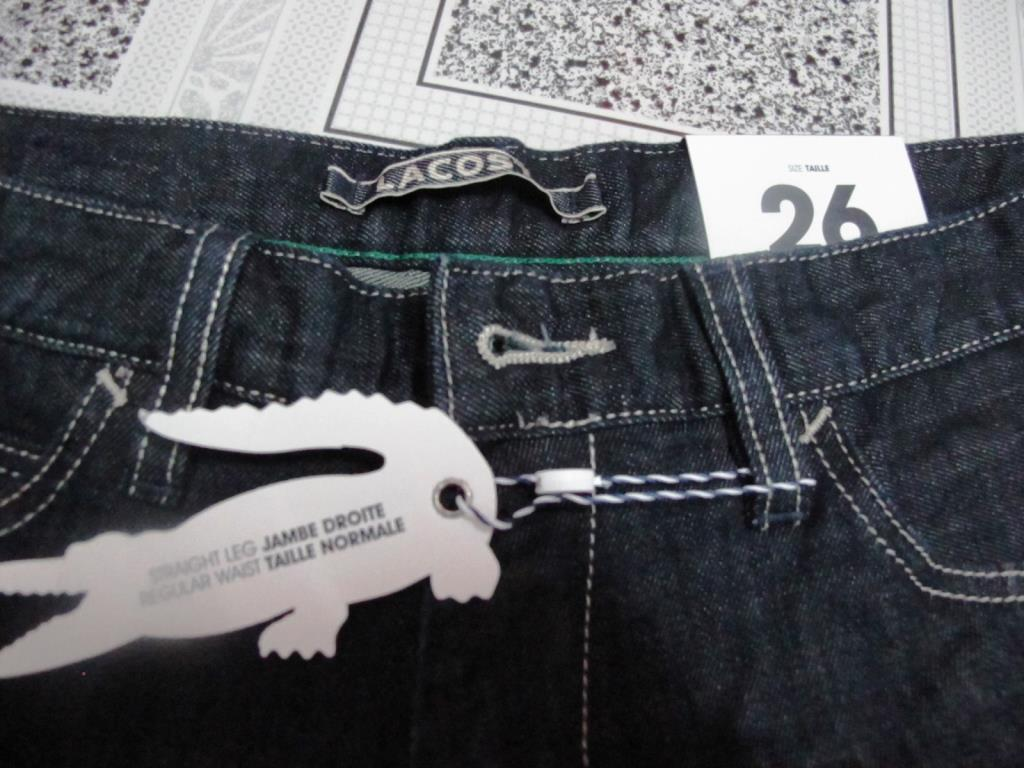What type of clothing item is in the image? There is a pair of jeans trousers in the image. What additional feature can be seen on the jeans trousers? The jeans trousers have a tag. What information is provided on the jeans trousers? There is a size card on the jeans trousers. How are the jeans trousers positioned in the image? The jeans trousers are placed on a cloth or an object. How many cows are visible in the image? There are no cows present in the image; it features a pair of jeans trousers. What type of copy is being made in the image? There is no copying activity depicted in the image; it shows a pair of jeans trousers with a tag and size card. 